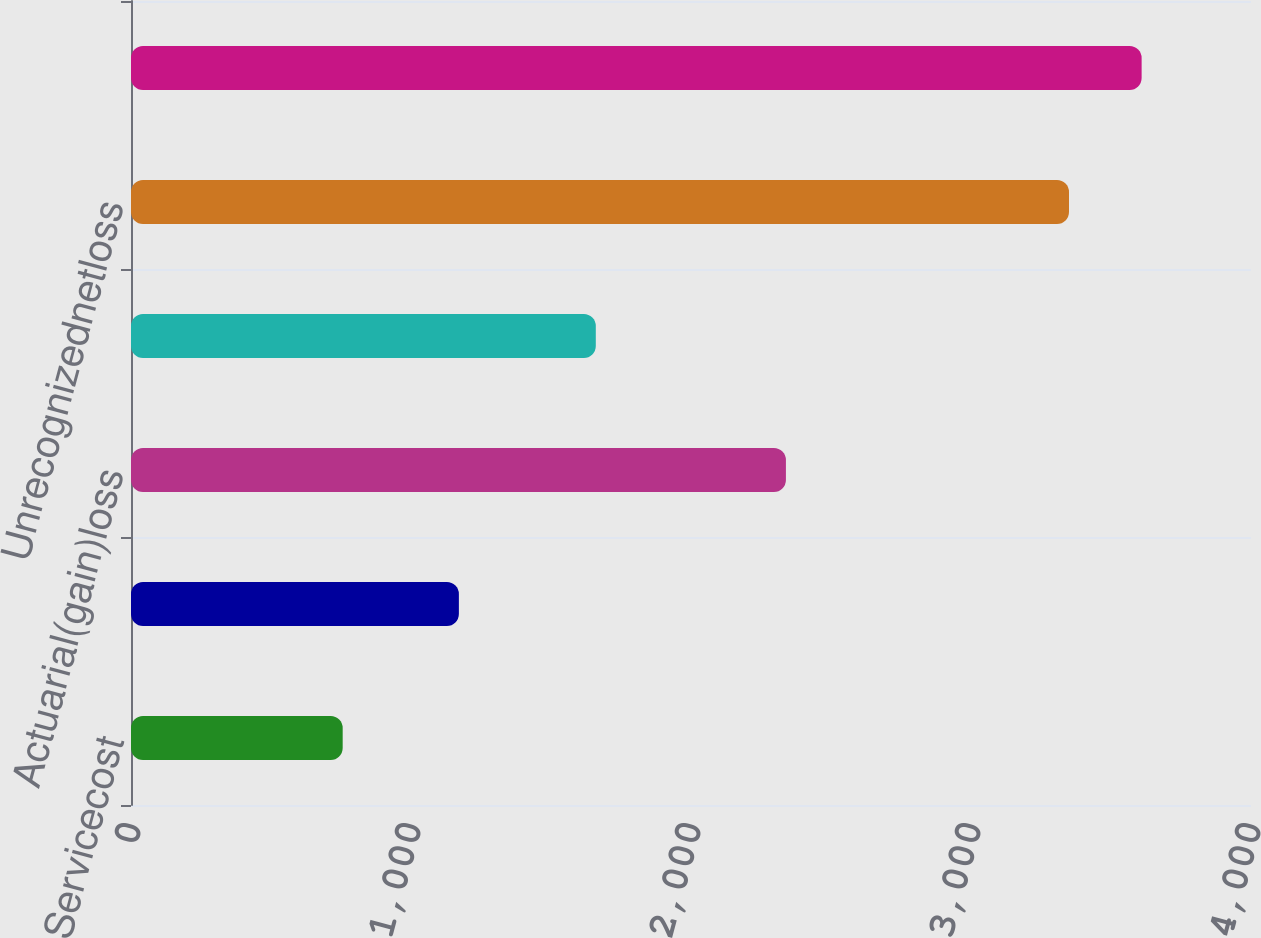<chart> <loc_0><loc_0><loc_500><loc_500><bar_chart><fcel>Servicecost<fcel>Interestcost<fcel>Actuarial(gain)loss<fcel>Benefitspaid<fcel>Unrecognizednetloss<fcel>Unnamed: 5<nl><fcel>756<fcel>1171<fcel>2339<fcel>1660<fcel>3350<fcel>3609.4<nl></chart> 